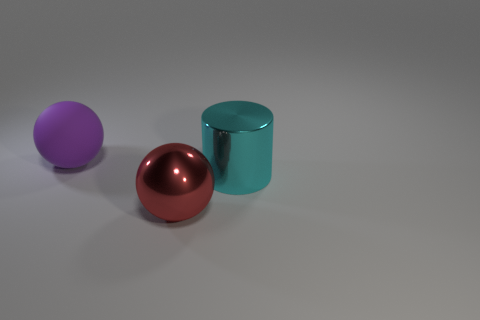There is a big object that is behind the large red thing and on the left side of the big cyan object; what shape is it?
Offer a very short reply. Sphere. Is there anything else that is the same size as the shiny cylinder?
Ensure brevity in your answer.  Yes. The shiny object on the right side of the sphere that is in front of the big cyan object is what color?
Give a very brief answer. Cyan. What shape is the thing that is in front of the large metal thing behind the big object in front of the big cyan metal cylinder?
Give a very brief answer. Sphere. There is a object that is both to the right of the purple rubber sphere and on the left side of the cyan metal object; how big is it?
Provide a short and direct response. Large. What number of metallic cylinders have the same color as the rubber thing?
Offer a very short reply. 0. What is the big cyan object made of?
Give a very brief answer. Metal. Are the object that is behind the cylinder and the red sphere made of the same material?
Offer a very short reply. No. What is the shape of the object in front of the large cyan cylinder?
Offer a very short reply. Sphere. There is a red sphere that is the same size as the cyan shiny cylinder; what material is it?
Keep it short and to the point. Metal. 